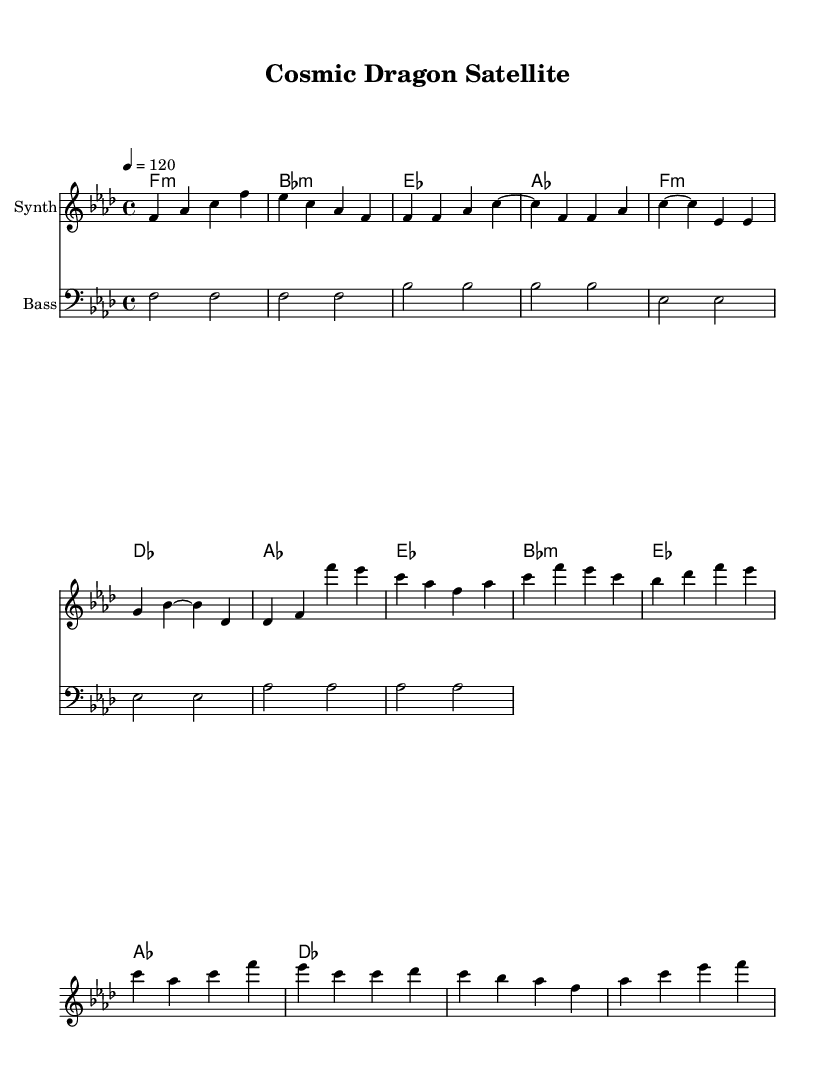What is the key signature of this music? The key signature is indicated in the global section of the code, which shows "\key f \minor". This means there are four flats in the key signature.
Answer: f minor What is the time signature of this music? The time signature is found in the global section of the code, where it states "\time 4/4". This means there are four beats in each measure and the quarter note gets one beat.
Answer: 4/4 What is the tempo marking for this piece? The tempo is indicated by "\tempo 4 = 120" in the global section of the code. This specifies that the quarter note should be played at a speed of 120 beats per minute.
Answer: 120 How many measures are in the verse section? By examining the melody part, it can be counted that the verse section consists of 8 measures: four in the first line and four in the second line (intro and verse are generally viewed as distinct).
Answer: 8 What is the genre of this music piece? The music piece features electronic instrumentation and a dance rhythm, characteristic of Disco. This can be inferred from the title "Cosmic Dragon Satellite" as well as the upbeat tempo and synthesizer-like instruments mentioned.
Answer: Disco What do the bass notes primarily consist of? The bass line is clearly provided, consisting primarily of notes like f, bes, and ees played as half notes. These notes repeatedly emphasize the root of the chords, tying the harmony and rhythm together.
Answer: root notes 